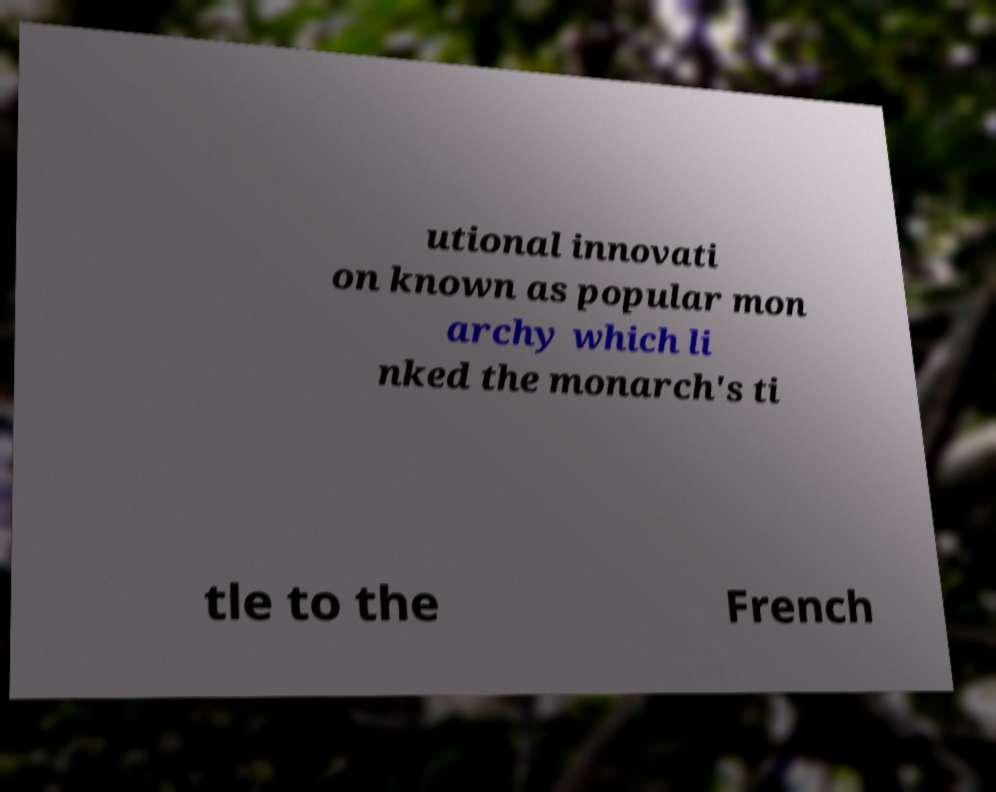Please read and relay the text visible in this image. What does it say? utional innovati on known as popular mon archy which li nked the monarch's ti tle to the French 